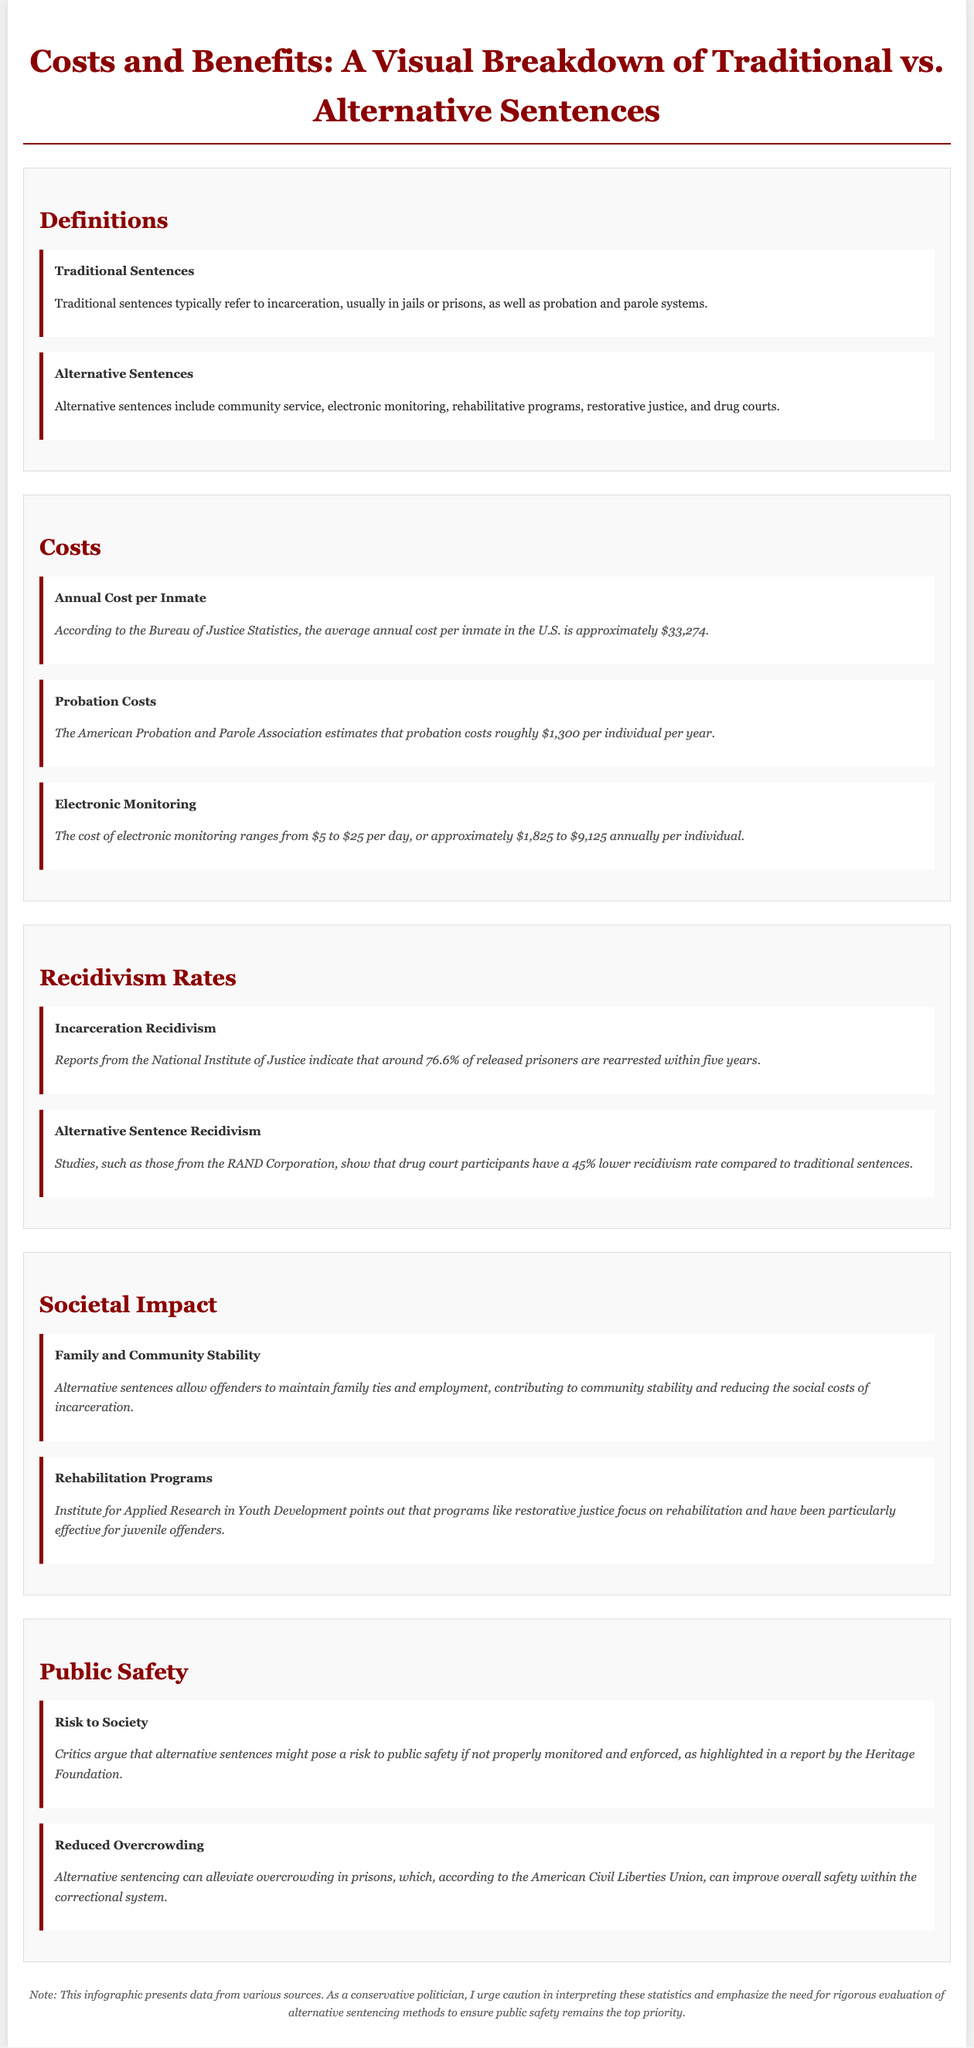What is the average annual cost per inmate in the U.S.? The average annual cost per inmate in the U.S. is approximately $33,274 according to the Bureau of Justice Statistics.
Answer: $33,274 What is the cost range for electronic monitoring per year? The cost of electronic monitoring ranges from $1,825 to $9,125 annually per individual.
Answer: $1,825 to $9,125 What percentage of released prisoners are rearrested within five years? Reports indicate that around 76.6% of released prisoners are rearrested within five years.
Answer: 76.6% What is the reduction in recidivism rate for drug court participants compared to traditional sentences? Studies show that drug court participants have a 45% lower recidivism rate compared to traditional sentences.
Answer: 45% What benefit do alternative sentences provide in terms of community stability? Alternative sentences allow offenders to maintain family ties and employment, contributing to community stability.
Answer: community stability What danger do critics highlight regarding alternative sentences? Critics argue that alternative sentences might pose a risk to public safety if not properly monitored and enforced.
Answer: public safety risk What organization estimates the annual cost of probation? The American Probation and Parole Association estimates that probation costs roughly $1,300 per individual per year.
Answer: American Probation and Parole Association What effect can alternative sentencing have on prison overcrowding? Alternative sentencing can alleviate overcrowding in prisons, improving overall safety within the correctional system.
Answer: alleviate overcrowding 